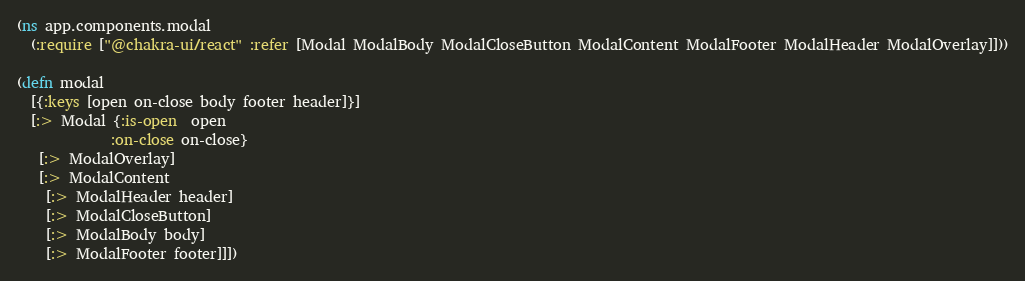Convert code to text. <code><loc_0><loc_0><loc_500><loc_500><_Clojure_>(ns app.components.modal
  (:require ["@chakra-ui/react" :refer [Modal ModalBody ModalCloseButton ModalContent ModalFooter ModalHeader ModalOverlay]]))

(defn modal
  [{:keys [open on-close body footer header]}]
  [:> Modal {:is-open  open
             :on-close on-close}
   [:> ModalOverlay]
   [:> ModalContent
    [:> ModalHeader header]
    [:> ModalCloseButton]
    [:> ModalBody body]
    [:> ModalFooter footer]]])

</code> 